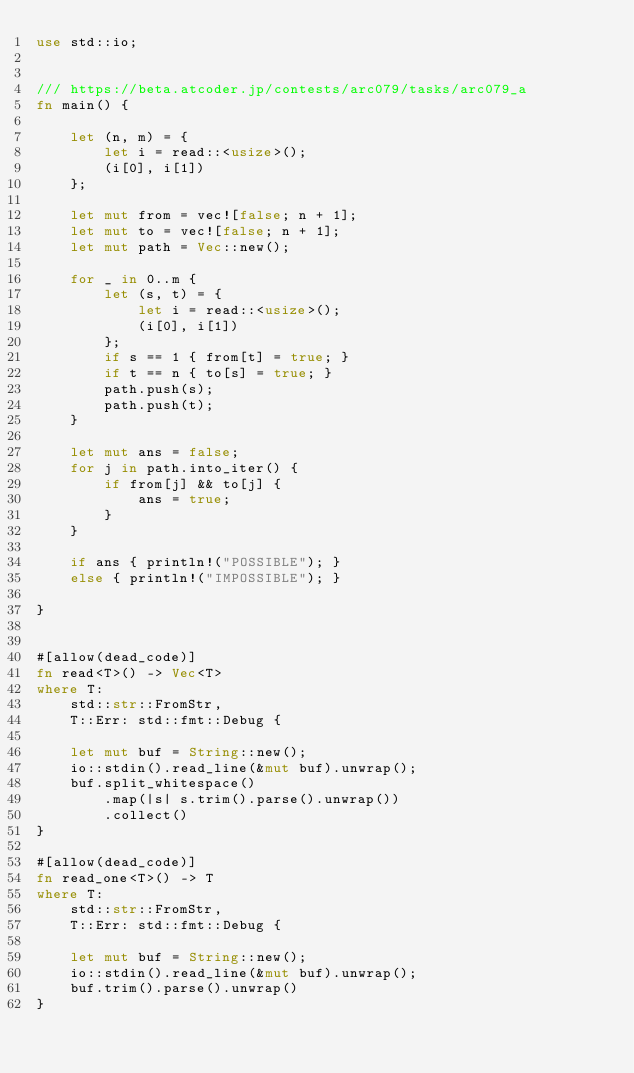<code> <loc_0><loc_0><loc_500><loc_500><_Rust_>use std::io;


/// https://beta.atcoder.jp/contests/arc079/tasks/arc079_a
fn main() {

    let (n, m) = {
        let i = read::<usize>();
        (i[0], i[1])
    };

    let mut from = vec![false; n + 1];
    let mut to = vec![false; n + 1];
    let mut path = Vec::new();

    for _ in 0..m {
        let (s, t) = {
            let i = read::<usize>();
            (i[0], i[1])
        };
        if s == 1 { from[t] = true; }
        if t == n { to[s] = true; }
        path.push(s);
        path.push(t);
    }

    let mut ans = false;
    for j in path.into_iter() {
        if from[j] && to[j] {
            ans = true;
        }
    }

    if ans { println!("POSSIBLE"); }
    else { println!("IMPOSSIBLE"); }

}


#[allow(dead_code)]
fn read<T>() -> Vec<T>
where T:
    std::str::FromStr,
    T::Err: std::fmt::Debug {

    let mut buf = String::new();
    io::stdin().read_line(&mut buf).unwrap();
    buf.split_whitespace()
        .map(|s| s.trim().parse().unwrap())
        .collect()
}

#[allow(dead_code)]
fn read_one<T>() -> T
where T:
    std::str::FromStr,
    T::Err: std::fmt::Debug {

    let mut buf = String::new();
    io::stdin().read_line(&mut buf).unwrap();
    buf.trim().parse().unwrap()
}</code> 